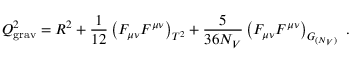<formula> <loc_0><loc_0><loc_500><loc_500>Q _ { g r a v } ^ { 2 } = R ^ { 2 } + { \frac { 1 } { 1 2 } } \left ( F _ { \mu \nu } F ^ { \mu \nu } \right ) _ { T ^ { 2 } } + { \frac { 5 } { 3 6 N _ { V } } } \left ( F _ { \mu \nu } F ^ { \mu \nu } \right ) _ { G _ { ( N _ { V } ) } } .</formula> 